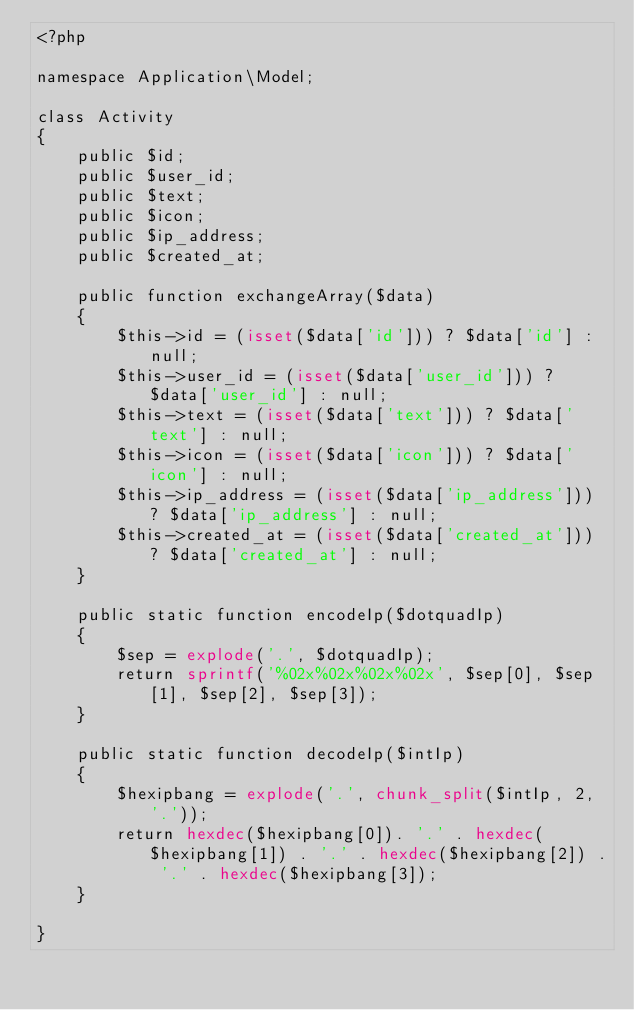Convert code to text. <code><loc_0><loc_0><loc_500><loc_500><_PHP_><?php

namespace Application\Model;

class Activity
{
    public $id;
    public $user_id;
    public $text;
    public $icon;
    public $ip_address;
    public $created_at;

    public function exchangeArray($data)
    {
        $this->id = (isset($data['id'])) ? $data['id'] : null;
        $this->user_id = (isset($data['user_id'])) ? $data['user_id'] : null;
        $this->text = (isset($data['text'])) ? $data['text'] : null;
        $this->icon = (isset($data['icon'])) ? $data['icon'] : null;
        $this->ip_address = (isset($data['ip_address'])) ? $data['ip_address'] : null;
        $this->created_at = (isset($data['created_at'])) ? $data['created_at'] : null;
    }
    
    public static function encodeIp($dotquadIp)
    {
        $sep = explode('.', $dotquadIp);
        return sprintf('%02x%02x%02x%02x', $sep[0], $sep[1], $sep[2], $sep[3]);
    }
    
    public static function decodeIp($intIp)
    {
        $hexipbang = explode('.', chunk_split($intIp, 2, '.'));
        return hexdec($hexipbang[0]). '.' . hexdec($hexipbang[1]) . '.' . hexdec($hexipbang[2]) . '.' . hexdec($hexipbang[3]);
    }
    
}
</code> 